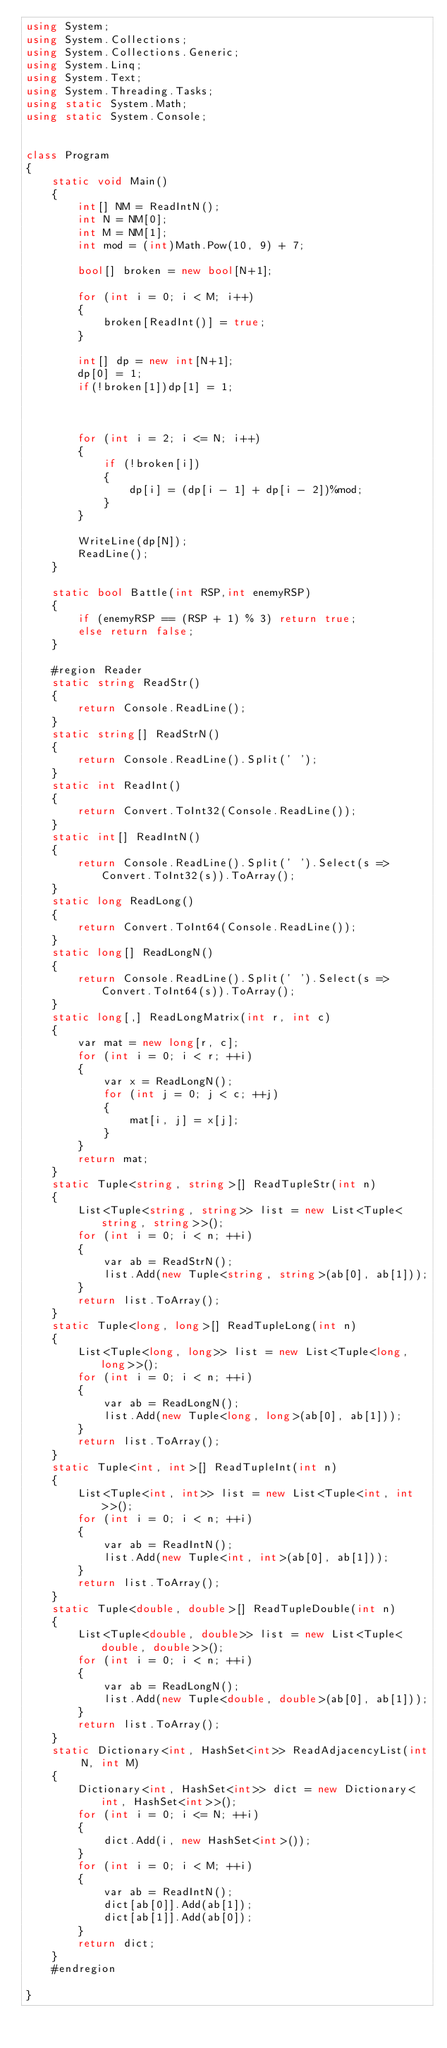<code> <loc_0><loc_0><loc_500><loc_500><_C#_>using System;
using System.Collections;
using System.Collections.Generic;
using System.Linq;
using System.Text;
using System.Threading.Tasks;
using static System.Math;
using static System.Console;


class Program
{
    static void Main()
    {
        int[] NM = ReadIntN();
        int N = NM[0];
        int M = NM[1];
        int mod = (int)Math.Pow(10, 9) + 7;

        bool[] broken = new bool[N+1];

        for (int i = 0; i < M; i++)
        {
            broken[ReadInt()] = true;
        }

        int[] dp = new int[N+1];
        dp[0] = 1;
        if(!broken[1])dp[1] = 1;



        for (int i = 2; i <= N; i++)
        {
            if (!broken[i])
            {
                dp[i] = (dp[i - 1] + dp[i - 2])%mod;
            }
        }

        WriteLine(dp[N]);
        ReadLine();
    }

    static bool Battle(int RSP,int enemyRSP)
    {
        if (enemyRSP == (RSP + 1) % 3) return true;
        else return false;
    }

    #region Reader
    static string ReadStr()
    {
        return Console.ReadLine();
    }
    static string[] ReadStrN()
    {
        return Console.ReadLine().Split(' ');
    }
    static int ReadInt()
    {
        return Convert.ToInt32(Console.ReadLine());
    }
    static int[] ReadIntN()
    {
        return Console.ReadLine().Split(' ').Select(s => Convert.ToInt32(s)).ToArray();
    }
    static long ReadLong()
    {
        return Convert.ToInt64(Console.ReadLine());
    }
    static long[] ReadLongN()
    {
        return Console.ReadLine().Split(' ').Select(s => Convert.ToInt64(s)).ToArray();
    }
    static long[,] ReadLongMatrix(int r, int c)
    {
        var mat = new long[r, c];
        for (int i = 0; i < r; ++i)
        {
            var x = ReadLongN();
            for (int j = 0; j < c; ++j)
            {
                mat[i, j] = x[j];
            }
        }
        return mat;
    }
    static Tuple<string, string>[] ReadTupleStr(int n)
    {
        List<Tuple<string, string>> list = new List<Tuple<string, string>>();
        for (int i = 0; i < n; ++i)
        {
            var ab = ReadStrN();
            list.Add(new Tuple<string, string>(ab[0], ab[1]));
        }
        return list.ToArray();
    }
    static Tuple<long, long>[] ReadTupleLong(int n)
    {
        List<Tuple<long, long>> list = new List<Tuple<long, long>>();
        for (int i = 0; i < n; ++i)
        {
            var ab = ReadLongN();
            list.Add(new Tuple<long, long>(ab[0], ab[1]));
        }
        return list.ToArray();
    }
    static Tuple<int, int>[] ReadTupleInt(int n)
    {
        List<Tuple<int, int>> list = new List<Tuple<int, int>>();
        for (int i = 0; i < n; ++i)
        {
            var ab = ReadIntN();
            list.Add(new Tuple<int, int>(ab[0], ab[1]));
        }
        return list.ToArray();
    }
    static Tuple<double, double>[] ReadTupleDouble(int n)
    {
        List<Tuple<double, double>> list = new List<Tuple<double, double>>();
        for (int i = 0; i < n; ++i)
        {
            var ab = ReadLongN();
            list.Add(new Tuple<double, double>(ab[0], ab[1]));
        }
        return list.ToArray();
    }
    static Dictionary<int, HashSet<int>> ReadAdjacencyList(int N, int M)
    {
        Dictionary<int, HashSet<int>> dict = new Dictionary<int, HashSet<int>>();
        for (int i = 0; i <= N; ++i)
        {
            dict.Add(i, new HashSet<int>());
        }
        for (int i = 0; i < M; ++i)
        {
            var ab = ReadIntN();
            dict[ab[0]].Add(ab[1]);
            dict[ab[1]].Add(ab[0]);
        }
        return dict;
    }
    #endregion

}</code> 